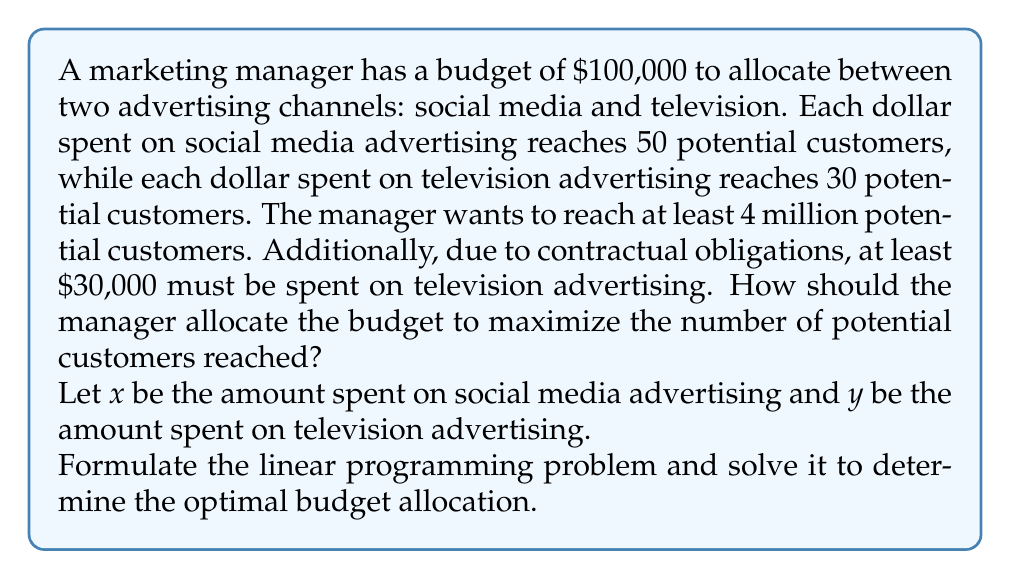Teach me how to tackle this problem. Let's approach this step-by-step:

1. Formulate the objective function:
   We want to maximize the number of potential customers reached.
   $$\text{Maximize: } 50x + 30y$$

2. Identify the constraints:
   a) Budget constraint: $$x + y \leq 100000$$
   b) Minimum reach constraint: $$50x + 30y \geq 4000000$$
   c) Minimum TV advertising constraint: $$y \geq 30000$$
   d) Non-negativity constraints: $$x \geq 0, y \geq 0$$

3. Set up the linear programming problem:
   $$\begin{align*}
   \text{Maximize: } & 50x + 30y \\
   \text{Subject to: } & x + y \leq 100000 \\
   & 50x + 30y \geq 4000000 \\
   & y \geq 30000 \\
   & x \geq 0, y \geq 0
   \end{align*}$$

4. Solve using the graphical method or simplex algorithm:
   The optimal solution will be at the intersection of constraints.

5. Check the corner points:
   a) (70000, 30000): Satisfies all constraints, reaches 4,600,000 customers
   b) (0, 100000): Violates minimum reach constraint
   c) (52000, 48000): Satisfies all constraints, reaches 4,600,000 customers

6. The optimal solution is either (70000, 30000) or (52000, 48000), both reaching 4,600,000 customers.

7. Since both solutions reach the same number of customers, we can choose either. Let's select (70000, 30000) as it allocates more to social media, which has a higher reach per dollar.
Answer: Optimal allocation: $70,000 on social media, $30,000 on television 